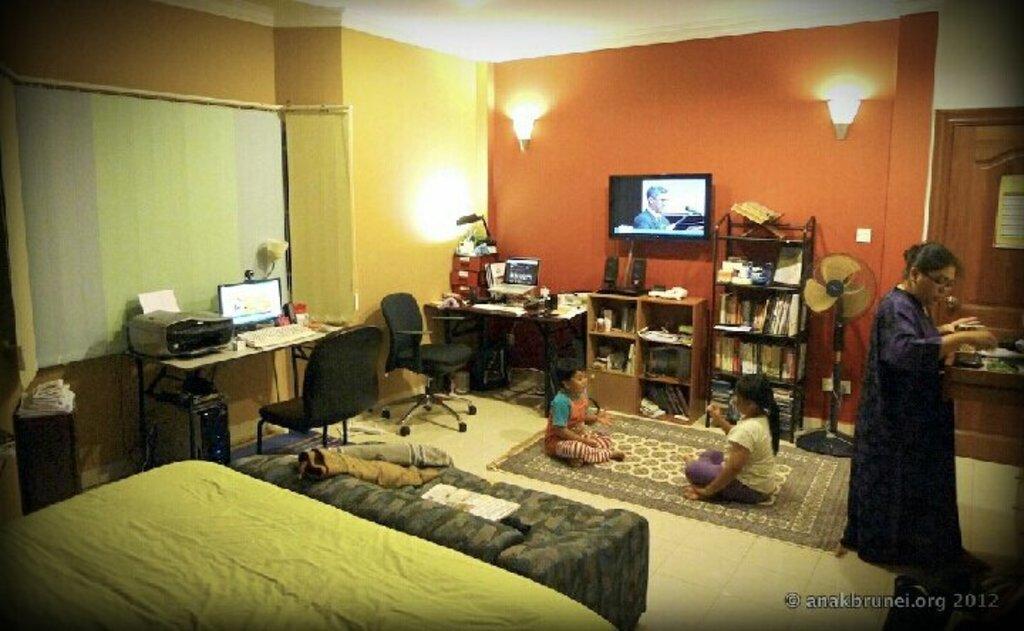In one or two sentences, can you explain what this image depicts? This image is clicked inside the room. In this image there are two kids sitting on the mat and playing with each other. On the left side there are beds. There is a television which is attached to the wall. Above the television there are two lights. In the middle there is a table on which there is a computer. In front of the computer there is a chair. In the background there are curtains. On the right side there is a woman standing on the floor and setting the things in the drawer. Beside her there is a door. There are cupboards and racks in which there are books. Beside the cupboard there is a table fan. On the left side there is a table on which there is a laptop. Beside the laptop there is a lamp and some boxes. 